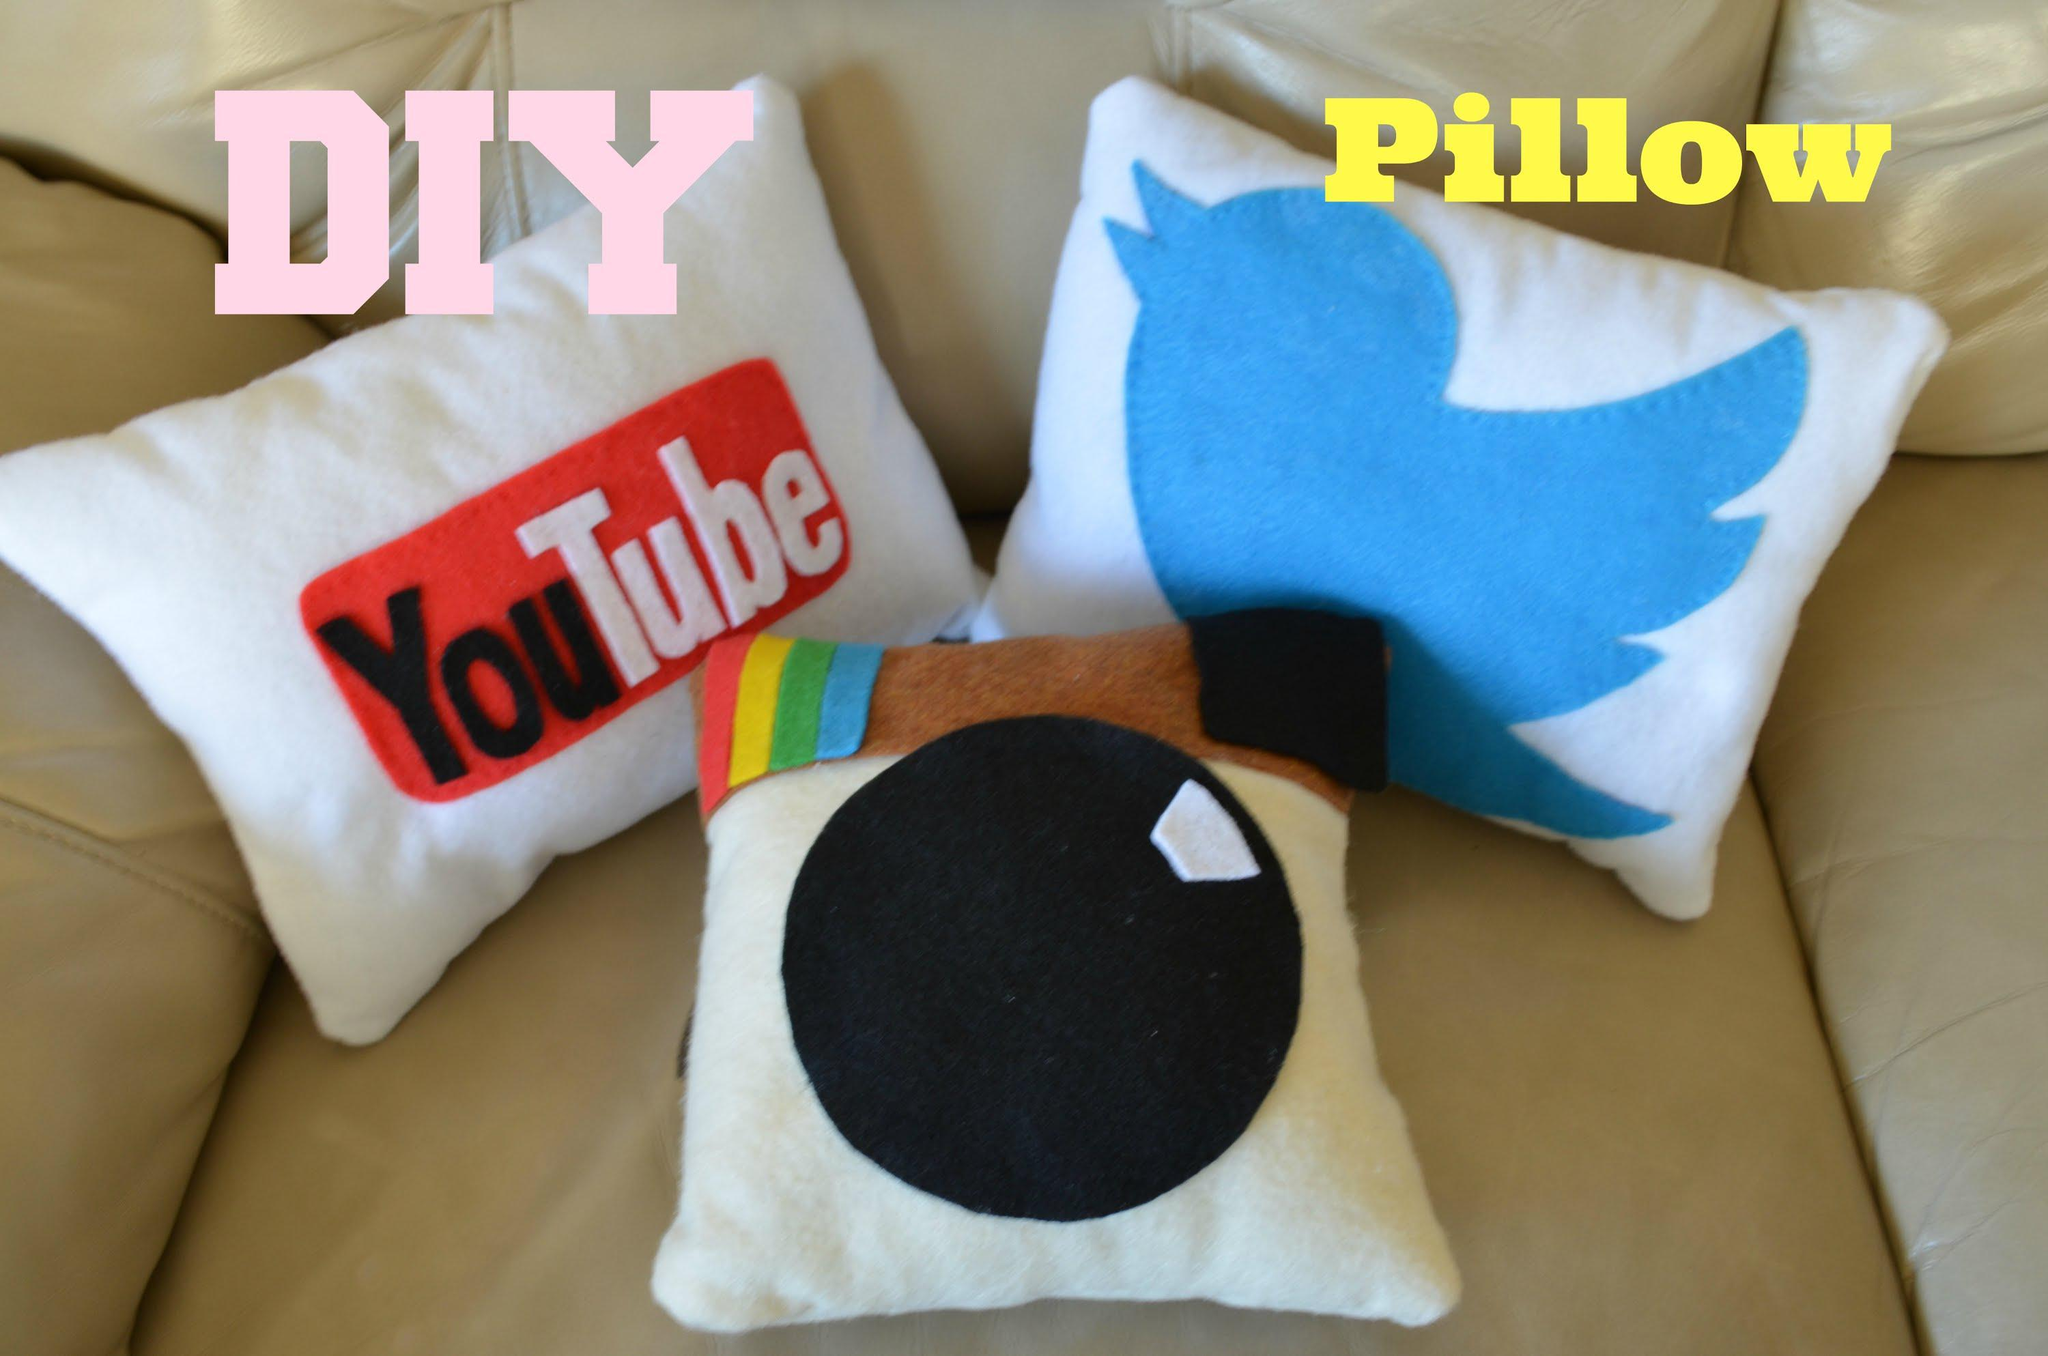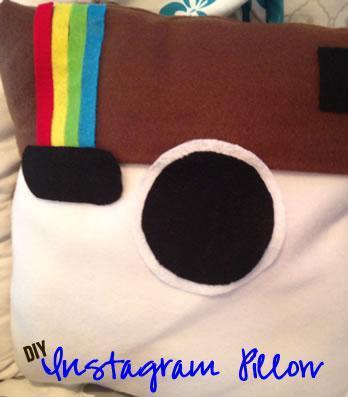The first image is the image on the left, the second image is the image on the right. For the images displayed, is the sentence "Each image includes a square pillow containing multiple rows of pictures, and in at least one image, the pictures on the pillow form a collage with no space between them." factually correct? Answer yes or no. No. The first image is the image on the left, the second image is the image on the right. Analyze the images presented: Is the assertion "At least one of the pillows is designed to look like the Instagram logo." valid? Answer yes or no. Yes. 